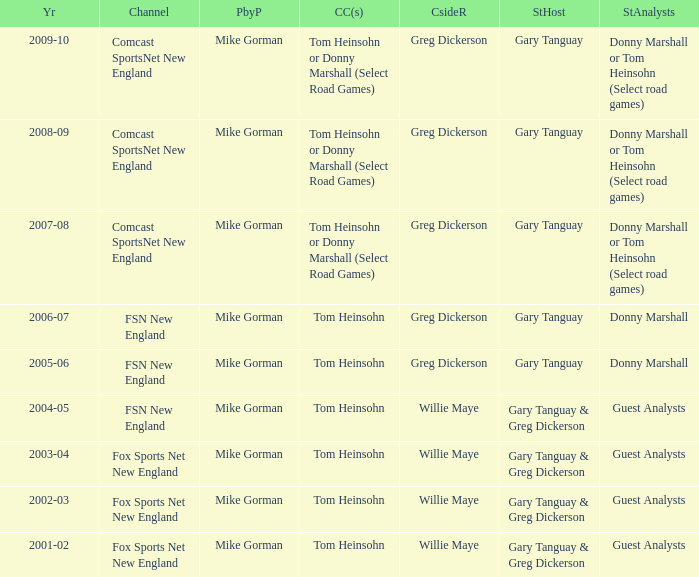How many channels were the games shown on in 2001-02? 1.0. Could you parse the entire table as a dict? {'header': ['Yr', 'Channel', 'PbyP', 'CC(s)', 'CsideR', 'StHost', 'StAnalysts'], 'rows': [['2009-10', 'Comcast SportsNet New England', 'Mike Gorman', 'Tom Heinsohn or Donny Marshall (Select Road Games)', 'Greg Dickerson', 'Gary Tanguay', 'Donny Marshall or Tom Heinsohn (Select road games)'], ['2008-09', 'Comcast SportsNet New England', 'Mike Gorman', 'Tom Heinsohn or Donny Marshall (Select Road Games)', 'Greg Dickerson', 'Gary Tanguay', 'Donny Marshall or Tom Heinsohn (Select road games)'], ['2007-08', 'Comcast SportsNet New England', 'Mike Gorman', 'Tom Heinsohn or Donny Marshall (Select Road Games)', 'Greg Dickerson', 'Gary Tanguay', 'Donny Marshall or Tom Heinsohn (Select road games)'], ['2006-07', 'FSN New England', 'Mike Gorman', 'Tom Heinsohn', 'Greg Dickerson', 'Gary Tanguay', 'Donny Marshall'], ['2005-06', 'FSN New England', 'Mike Gorman', 'Tom Heinsohn', 'Greg Dickerson', 'Gary Tanguay', 'Donny Marshall'], ['2004-05', 'FSN New England', 'Mike Gorman', 'Tom Heinsohn', 'Willie Maye', 'Gary Tanguay & Greg Dickerson', 'Guest Analysts'], ['2003-04', 'Fox Sports Net New England', 'Mike Gorman', 'Tom Heinsohn', 'Willie Maye', 'Gary Tanguay & Greg Dickerson', 'Guest Analysts'], ['2002-03', 'Fox Sports Net New England', 'Mike Gorman', 'Tom Heinsohn', 'Willie Maye', 'Gary Tanguay & Greg Dickerson', 'Guest Analysts'], ['2001-02', 'Fox Sports Net New England', 'Mike Gorman', 'Tom Heinsohn', 'Willie Maye', 'Gary Tanguay & Greg Dickerson', 'Guest Analysts']]} 